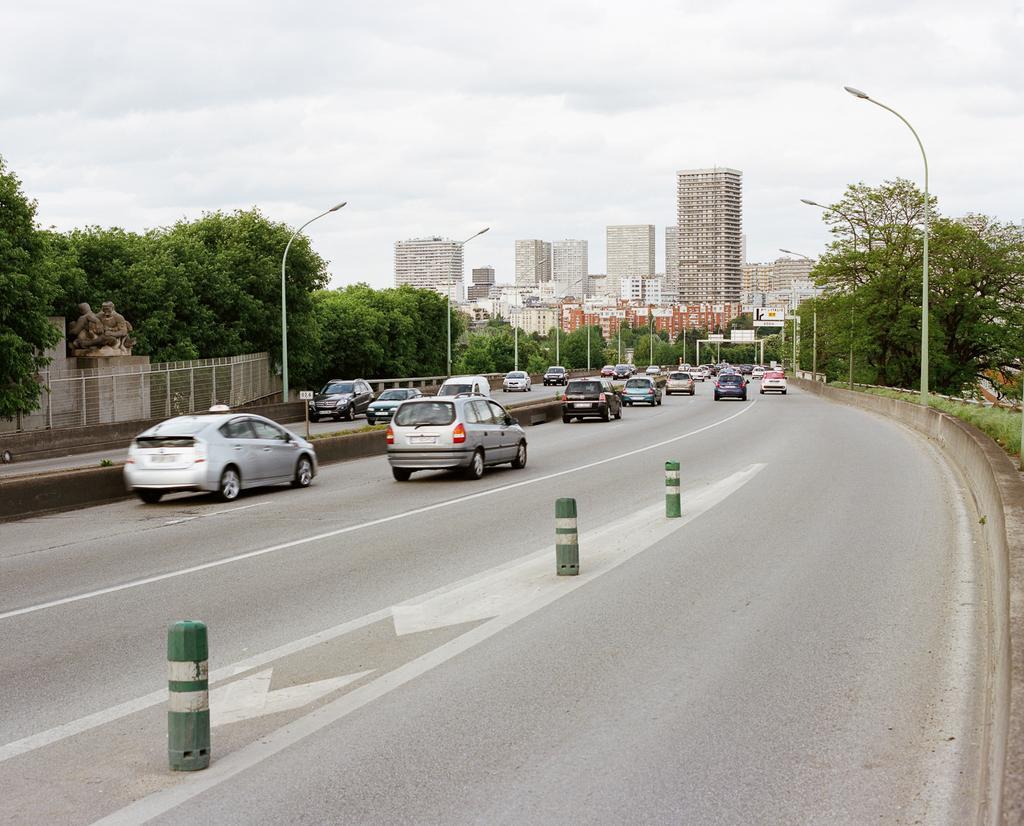Please provide a concise description of this image. In this picture I can see few buildings trees and few pole lights and few cars moving on the road and a metal fence on the left side and a cloudy sky. 